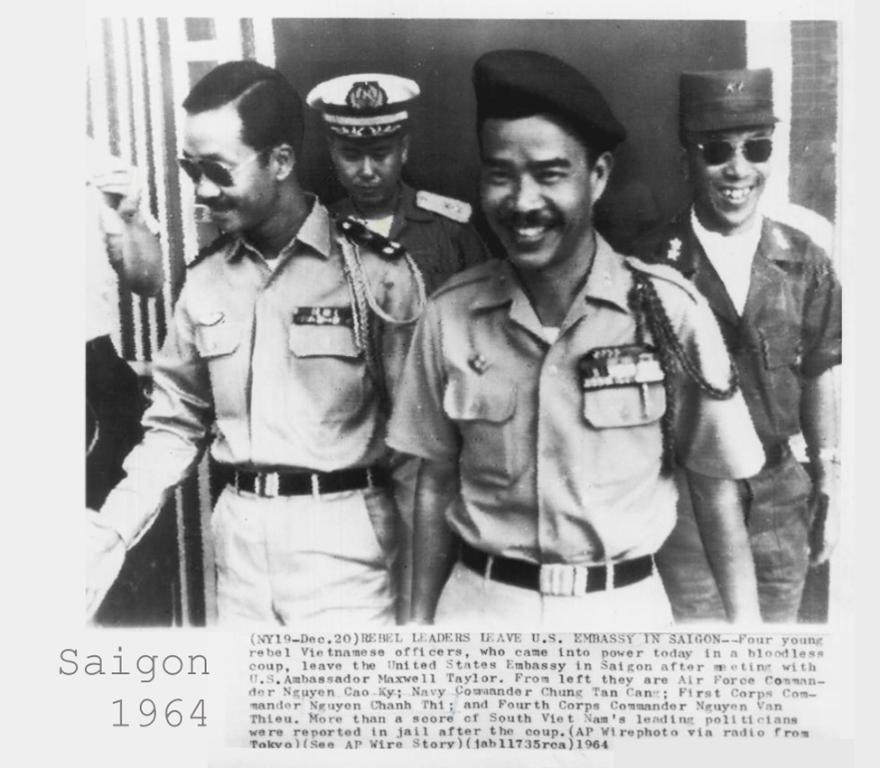How would you summarize this image in a sentence or two? In this picture we can see a paper, there is a photograph of four persons on the paper, three of them are smiling, at the bottom there is some text. 